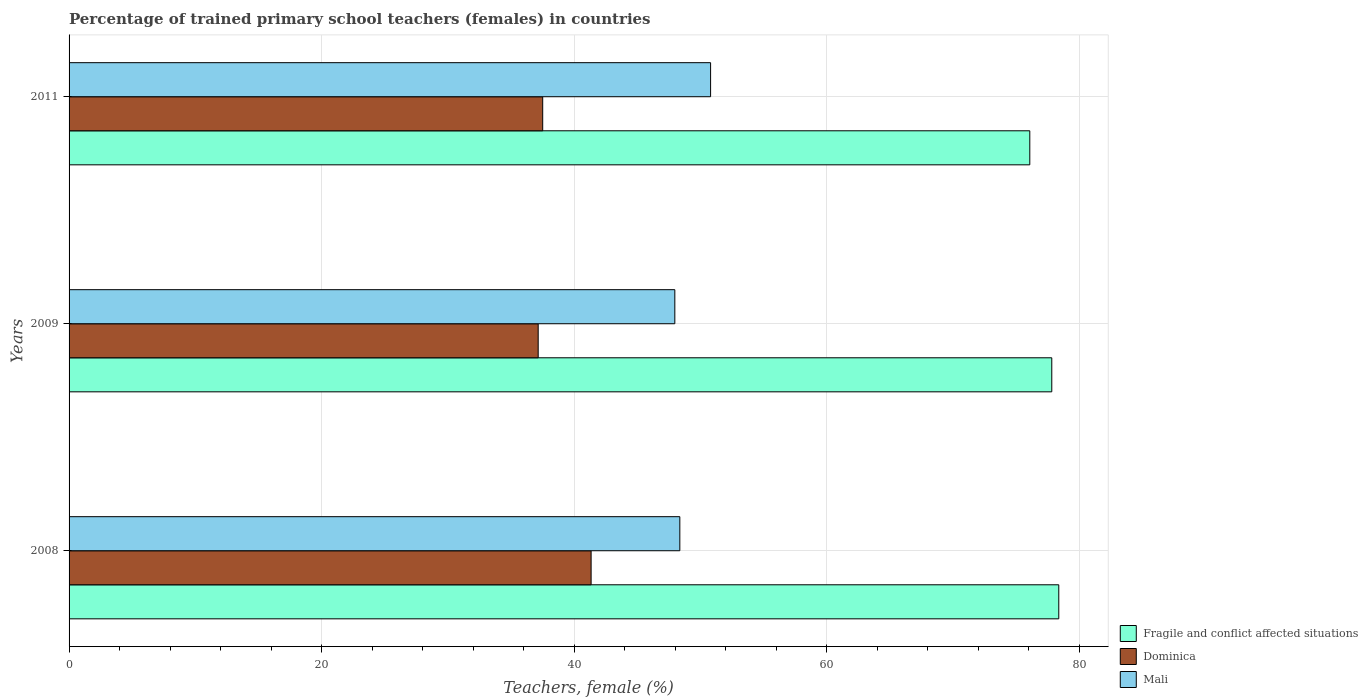How many different coloured bars are there?
Your response must be concise. 3. How many groups of bars are there?
Provide a short and direct response. 3. How many bars are there on the 2nd tick from the top?
Your response must be concise. 3. What is the label of the 2nd group of bars from the top?
Your answer should be compact. 2009. What is the percentage of trained primary school teachers (females) in Dominica in 2008?
Provide a short and direct response. 41.33. Across all years, what is the maximum percentage of trained primary school teachers (females) in Fragile and conflict affected situations?
Give a very brief answer. 78.36. Across all years, what is the minimum percentage of trained primary school teachers (females) in Dominica?
Your response must be concise. 37.14. In which year was the percentage of trained primary school teachers (females) in Dominica maximum?
Provide a succinct answer. 2008. What is the total percentage of trained primary school teachers (females) in Fragile and conflict affected situations in the graph?
Your answer should be very brief. 232.23. What is the difference between the percentage of trained primary school teachers (females) in Fragile and conflict affected situations in 2008 and that in 2009?
Provide a succinct answer. 0.56. What is the difference between the percentage of trained primary school teachers (females) in Fragile and conflict affected situations in 2011 and the percentage of trained primary school teachers (females) in Dominica in 2008?
Your answer should be compact. 34.73. What is the average percentage of trained primary school teachers (females) in Mali per year?
Your answer should be very brief. 49.04. In the year 2008, what is the difference between the percentage of trained primary school teachers (females) in Mali and percentage of trained primary school teachers (females) in Fragile and conflict affected situations?
Provide a succinct answer. -30.01. What is the ratio of the percentage of trained primary school teachers (females) in Fragile and conflict affected situations in 2009 to that in 2011?
Provide a succinct answer. 1.02. Is the percentage of trained primary school teachers (females) in Fragile and conflict affected situations in 2009 less than that in 2011?
Provide a short and direct response. No. What is the difference between the highest and the second highest percentage of trained primary school teachers (females) in Dominica?
Offer a very short reply. 3.83. What is the difference between the highest and the lowest percentage of trained primary school teachers (females) in Mali?
Offer a very short reply. 2.83. What does the 2nd bar from the top in 2009 represents?
Ensure brevity in your answer.  Dominica. What does the 2nd bar from the bottom in 2011 represents?
Offer a very short reply. Dominica. Is it the case that in every year, the sum of the percentage of trained primary school teachers (females) in Dominica and percentage of trained primary school teachers (females) in Fragile and conflict affected situations is greater than the percentage of trained primary school teachers (females) in Mali?
Make the answer very short. Yes. How many years are there in the graph?
Offer a very short reply. 3. Are the values on the major ticks of X-axis written in scientific E-notation?
Ensure brevity in your answer.  No. Does the graph contain any zero values?
Keep it short and to the point. No. Where does the legend appear in the graph?
Your answer should be compact. Bottom right. What is the title of the graph?
Provide a short and direct response. Percentage of trained primary school teachers (females) in countries. What is the label or title of the X-axis?
Offer a terse response. Teachers, female (%). What is the label or title of the Y-axis?
Keep it short and to the point. Years. What is the Teachers, female (%) of Fragile and conflict affected situations in 2008?
Keep it short and to the point. 78.36. What is the Teachers, female (%) of Dominica in 2008?
Offer a terse response. 41.33. What is the Teachers, female (%) of Mali in 2008?
Your answer should be compact. 48.36. What is the Teachers, female (%) in Fragile and conflict affected situations in 2009?
Make the answer very short. 77.81. What is the Teachers, female (%) of Dominica in 2009?
Your answer should be compact. 37.14. What is the Teachers, female (%) of Mali in 2009?
Your answer should be very brief. 47.96. What is the Teachers, female (%) in Fragile and conflict affected situations in 2011?
Your answer should be very brief. 76.07. What is the Teachers, female (%) in Dominica in 2011?
Provide a succinct answer. 37.5. What is the Teachers, female (%) in Mali in 2011?
Offer a terse response. 50.79. Across all years, what is the maximum Teachers, female (%) in Fragile and conflict affected situations?
Give a very brief answer. 78.36. Across all years, what is the maximum Teachers, female (%) in Dominica?
Your answer should be very brief. 41.33. Across all years, what is the maximum Teachers, female (%) of Mali?
Ensure brevity in your answer.  50.79. Across all years, what is the minimum Teachers, female (%) in Fragile and conflict affected situations?
Ensure brevity in your answer.  76.07. Across all years, what is the minimum Teachers, female (%) in Dominica?
Provide a short and direct response. 37.14. Across all years, what is the minimum Teachers, female (%) of Mali?
Give a very brief answer. 47.96. What is the total Teachers, female (%) of Fragile and conflict affected situations in the graph?
Offer a very short reply. 232.23. What is the total Teachers, female (%) in Dominica in the graph?
Offer a very short reply. 115.98. What is the total Teachers, female (%) in Mali in the graph?
Your answer should be very brief. 147.11. What is the difference between the Teachers, female (%) in Fragile and conflict affected situations in 2008 and that in 2009?
Your response must be concise. 0.56. What is the difference between the Teachers, female (%) in Dominica in 2008 and that in 2009?
Provide a succinct answer. 4.19. What is the difference between the Teachers, female (%) of Mali in 2008 and that in 2009?
Ensure brevity in your answer.  0.4. What is the difference between the Teachers, female (%) in Fragile and conflict affected situations in 2008 and that in 2011?
Give a very brief answer. 2.3. What is the difference between the Teachers, female (%) of Dominica in 2008 and that in 2011?
Provide a succinct answer. 3.83. What is the difference between the Teachers, female (%) of Mali in 2008 and that in 2011?
Provide a short and direct response. -2.44. What is the difference between the Teachers, female (%) in Fragile and conflict affected situations in 2009 and that in 2011?
Offer a very short reply. 1.74. What is the difference between the Teachers, female (%) in Dominica in 2009 and that in 2011?
Give a very brief answer. -0.36. What is the difference between the Teachers, female (%) in Mali in 2009 and that in 2011?
Ensure brevity in your answer.  -2.83. What is the difference between the Teachers, female (%) of Fragile and conflict affected situations in 2008 and the Teachers, female (%) of Dominica in 2009?
Keep it short and to the point. 41.22. What is the difference between the Teachers, female (%) in Fragile and conflict affected situations in 2008 and the Teachers, female (%) in Mali in 2009?
Offer a very short reply. 30.4. What is the difference between the Teachers, female (%) of Dominica in 2008 and the Teachers, female (%) of Mali in 2009?
Keep it short and to the point. -6.63. What is the difference between the Teachers, female (%) of Fragile and conflict affected situations in 2008 and the Teachers, female (%) of Dominica in 2011?
Offer a very short reply. 40.86. What is the difference between the Teachers, female (%) in Fragile and conflict affected situations in 2008 and the Teachers, female (%) in Mali in 2011?
Your answer should be compact. 27.57. What is the difference between the Teachers, female (%) of Dominica in 2008 and the Teachers, female (%) of Mali in 2011?
Keep it short and to the point. -9.46. What is the difference between the Teachers, female (%) in Fragile and conflict affected situations in 2009 and the Teachers, female (%) in Dominica in 2011?
Offer a terse response. 40.31. What is the difference between the Teachers, female (%) in Fragile and conflict affected situations in 2009 and the Teachers, female (%) in Mali in 2011?
Keep it short and to the point. 27.01. What is the difference between the Teachers, female (%) of Dominica in 2009 and the Teachers, female (%) of Mali in 2011?
Provide a succinct answer. -13.65. What is the average Teachers, female (%) of Fragile and conflict affected situations per year?
Keep it short and to the point. 77.41. What is the average Teachers, female (%) of Dominica per year?
Keep it short and to the point. 38.66. What is the average Teachers, female (%) in Mali per year?
Keep it short and to the point. 49.04. In the year 2008, what is the difference between the Teachers, female (%) in Fragile and conflict affected situations and Teachers, female (%) in Dominica?
Provide a short and direct response. 37.03. In the year 2008, what is the difference between the Teachers, female (%) of Fragile and conflict affected situations and Teachers, female (%) of Mali?
Your response must be concise. 30.01. In the year 2008, what is the difference between the Teachers, female (%) of Dominica and Teachers, female (%) of Mali?
Make the answer very short. -7.02. In the year 2009, what is the difference between the Teachers, female (%) of Fragile and conflict affected situations and Teachers, female (%) of Dominica?
Offer a very short reply. 40.66. In the year 2009, what is the difference between the Teachers, female (%) of Fragile and conflict affected situations and Teachers, female (%) of Mali?
Your answer should be very brief. 29.85. In the year 2009, what is the difference between the Teachers, female (%) in Dominica and Teachers, female (%) in Mali?
Your response must be concise. -10.82. In the year 2011, what is the difference between the Teachers, female (%) in Fragile and conflict affected situations and Teachers, female (%) in Dominica?
Provide a succinct answer. 38.57. In the year 2011, what is the difference between the Teachers, female (%) of Fragile and conflict affected situations and Teachers, female (%) of Mali?
Provide a short and direct response. 25.27. In the year 2011, what is the difference between the Teachers, female (%) in Dominica and Teachers, female (%) in Mali?
Offer a terse response. -13.29. What is the ratio of the Teachers, female (%) of Fragile and conflict affected situations in 2008 to that in 2009?
Provide a succinct answer. 1.01. What is the ratio of the Teachers, female (%) of Dominica in 2008 to that in 2009?
Your response must be concise. 1.11. What is the ratio of the Teachers, female (%) of Mali in 2008 to that in 2009?
Your answer should be very brief. 1.01. What is the ratio of the Teachers, female (%) of Fragile and conflict affected situations in 2008 to that in 2011?
Make the answer very short. 1.03. What is the ratio of the Teachers, female (%) in Dominica in 2008 to that in 2011?
Provide a succinct answer. 1.1. What is the ratio of the Teachers, female (%) in Mali in 2008 to that in 2011?
Keep it short and to the point. 0.95. What is the ratio of the Teachers, female (%) of Fragile and conflict affected situations in 2009 to that in 2011?
Offer a terse response. 1.02. What is the ratio of the Teachers, female (%) of Mali in 2009 to that in 2011?
Keep it short and to the point. 0.94. What is the difference between the highest and the second highest Teachers, female (%) of Fragile and conflict affected situations?
Keep it short and to the point. 0.56. What is the difference between the highest and the second highest Teachers, female (%) in Dominica?
Your answer should be compact. 3.83. What is the difference between the highest and the second highest Teachers, female (%) of Mali?
Ensure brevity in your answer.  2.44. What is the difference between the highest and the lowest Teachers, female (%) in Fragile and conflict affected situations?
Offer a very short reply. 2.3. What is the difference between the highest and the lowest Teachers, female (%) in Dominica?
Your response must be concise. 4.19. What is the difference between the highest and the lowest Teachers, female (%) in Mali?
Provide a short and direct response. 2.83. 